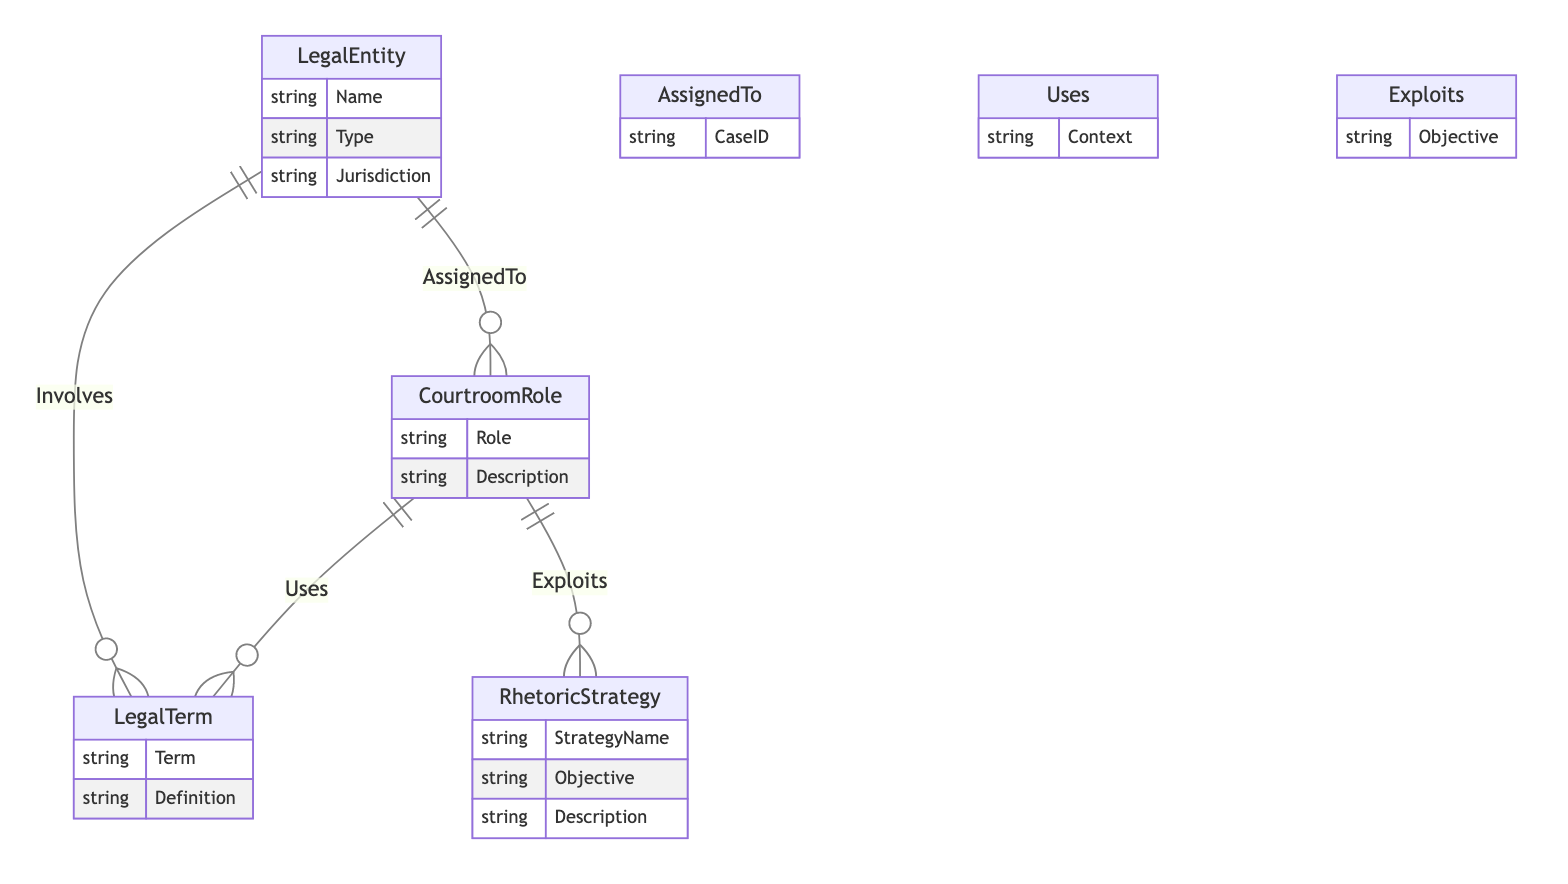What's the total number of entities in the diagram? There are four distinct entities identified in the diagram: LegalEntity, LegalTerm, CourtroomRole, and RhetoricStrategy.
Answer: 4 What attribute does the LegalEntity have? The LegalEntity has three attributes listed: Name, Type, and Jurisdiction, which describe different aspects of this entity.
Answer: Name, Type, Jurisdiction Which courtroom role exploits the rhetoric strategy? The diagram specifies that the CourtroomRole exploits a RhetoricStrategy, indicating that every courtroom role has the potential to leverage rhetorical strategies during trials.
Answer: CourtroomRole How many relationships connect LegalEntity to LegalTerm? The diagram shows a single relationship named "Involves," which connects the LegalEntity with the LegalTerm, indicating its direct link.
Answer: 1 What is the context attribute used for in the diagram? The context attribute is used in the "Uses" relationship to connect CourtroomRole with LegalTerm, specifying the scenario in which a particular legal term is utilized.
Answer: Context How many attributes does RhetoricStrategy have? RhetoricStrategy consists of three attributes: StrategyName, Objective, and Description, providing a detailed understanding of its elements.
Answer: 3 Which legal entity is linked to courtroom roles? The diagram shows that a LegalEntity is linked to CourtroomRole through the "AssignedTo" relationship, meaning there is a connection between legal entities and their respective roles in court.
Answer: LegalEntity What is the purpose of the "Exploits" relationship? The "Exploits" relationship serves to demonstrate how various courtroom roles utilize rhetoric strategies with specific objectives, indicating a strategic approach to their legal functions.
Answer: Objective Which term is defined as "used in legal discourse"? The definition for the term that relates to its function in legal discourse can be derived from the LegalTerm, but in the provided data, specifics are not indicated. This is a broader call for what would need to be explicitly defined in a practical legal setting.
Answer: LegalTerm 